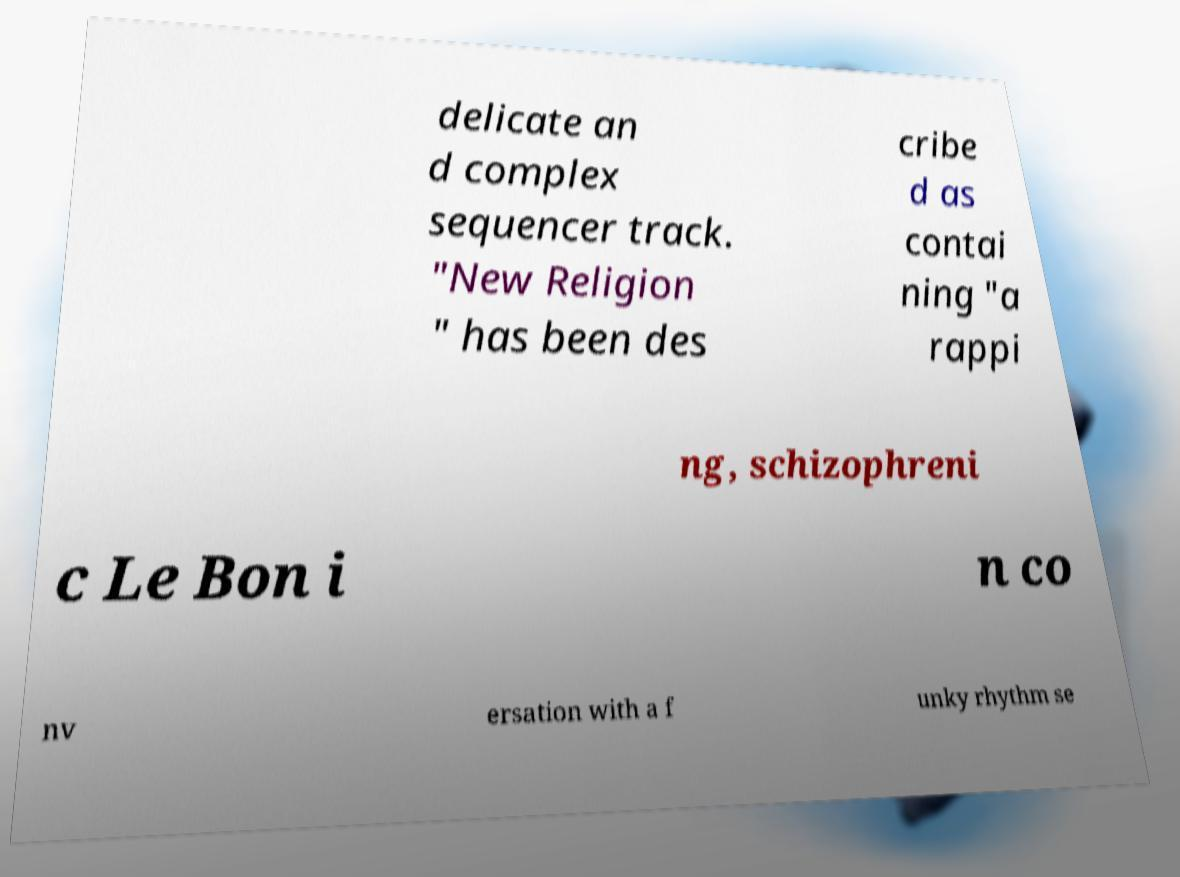Please identify and transcribe the text found in this image. delicate an d complex sequencer track. "New Religion " has been des cribe d as contai ning "a rappi ng, schizophreni c Le Bon i n co nv ersation with a f unky rhythm se 